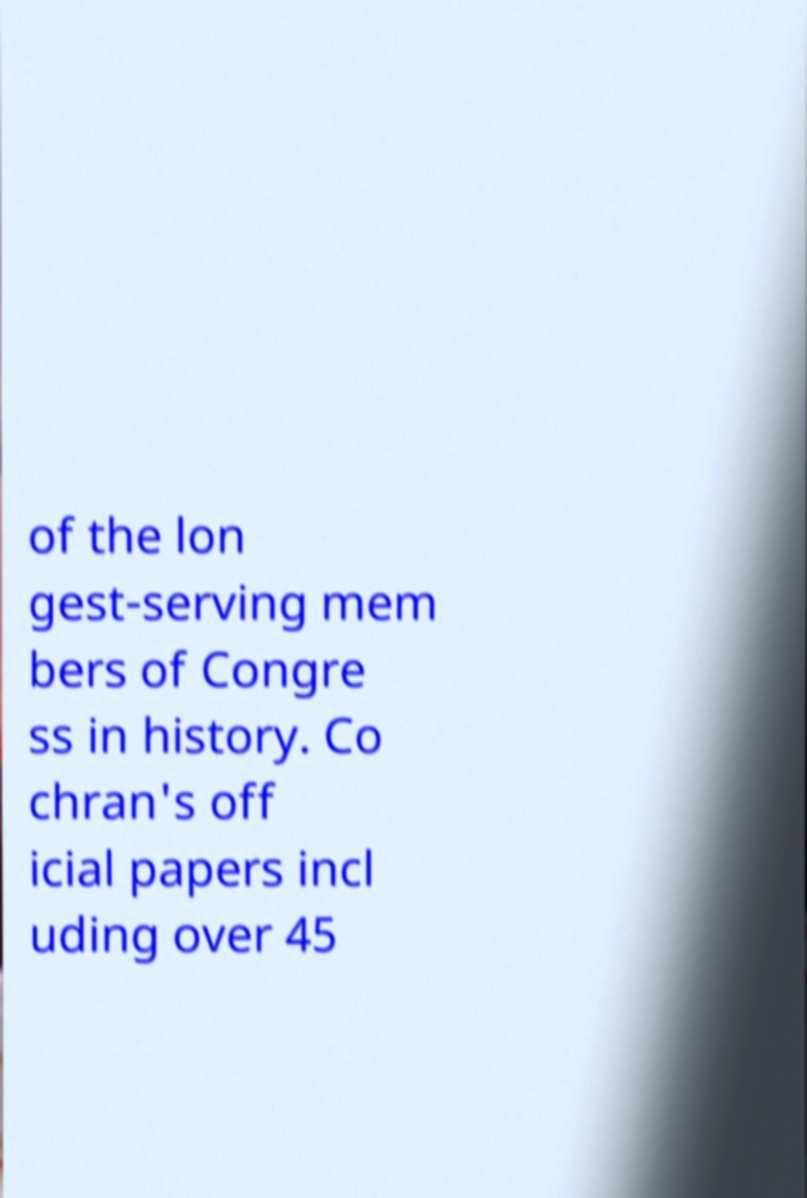Can you accurately transcribe the text from the provided image for me? of the lon gest-serving mem bers of Congre ss in history. Co chran's off icial papers incl uding over 45 